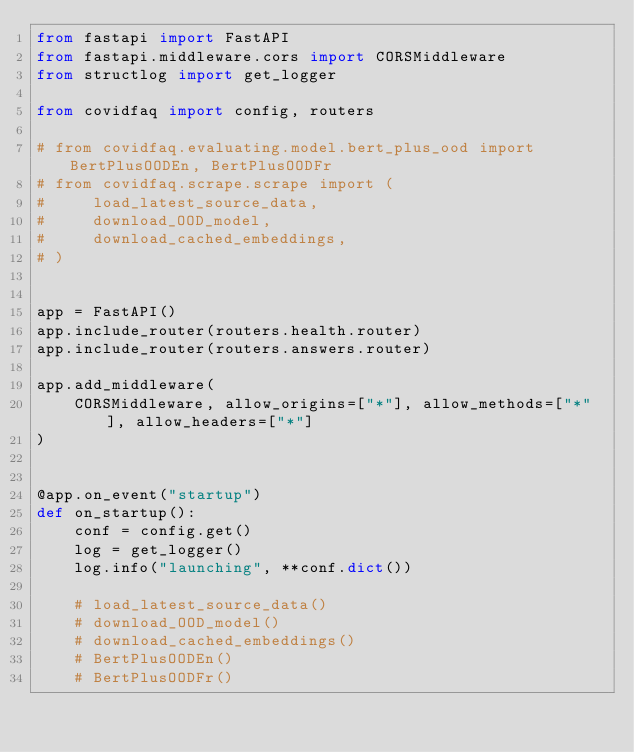<code> <loc_0><loc_0><loc_500><loc_500><_Python_>from fastapi import FastAPI
from fastapi.middleware.cors import CORSMiddleware
from structlog import get_logger

from covidfaq import config, routers

# from covidfaq.evaluating.model.bert_plus_ood import BertPlusOODEn, BertPlusOODFr
# from covidfaq.scrape.scrape import (
#     load_latest_source_data,
#     download_OOD_model,
#     download_cached_embeddings,
# )


app = FastAPI()
app.include_router(routers.health.router)
app.include_router(routers.answers.router)

app.add_middleware(
    CORSMiddleware, allow_origins=["*"], allow_methods=["*"], allow_headers=["*"]
)


@app.on_event("startup")
def on_startup():
    conf = config.get()
    log = get_logger()
    log.info("launching", **conf.dict())

    # load_latest_source_data()
    # download_OOD_model()
    # download_cached_embeddings()
    # BertPlusOODEn()
    # BertPlusOODFr()
</code> 